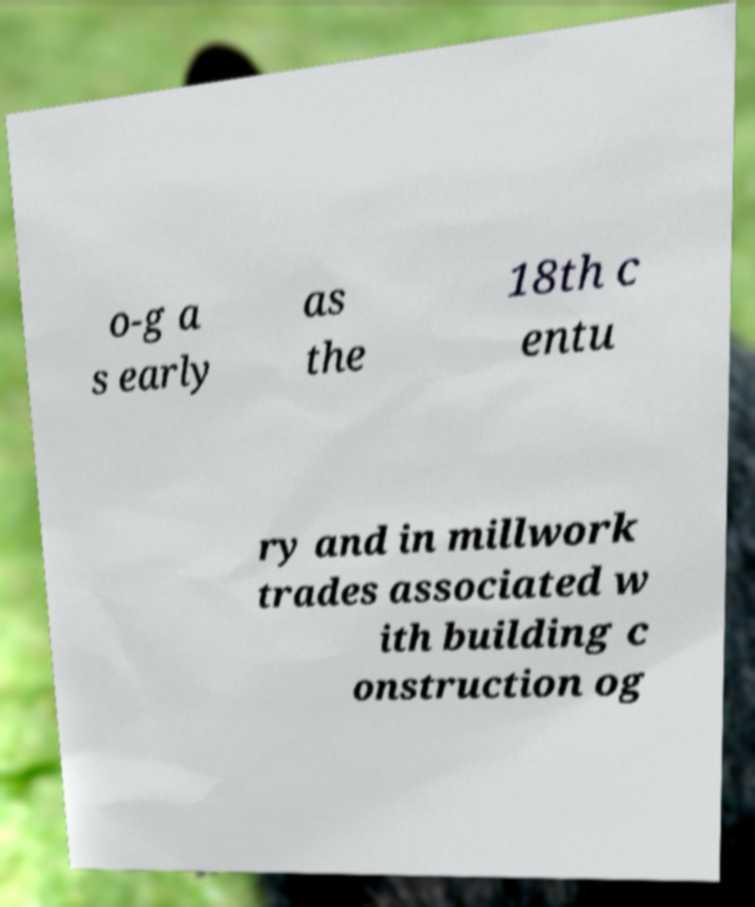There's text embedded in this image that I need extracted. Can you transcribe it verbatim? o-g a s early as the 18th c entu ry and in millwork trades associated w ith building c onstruction og 